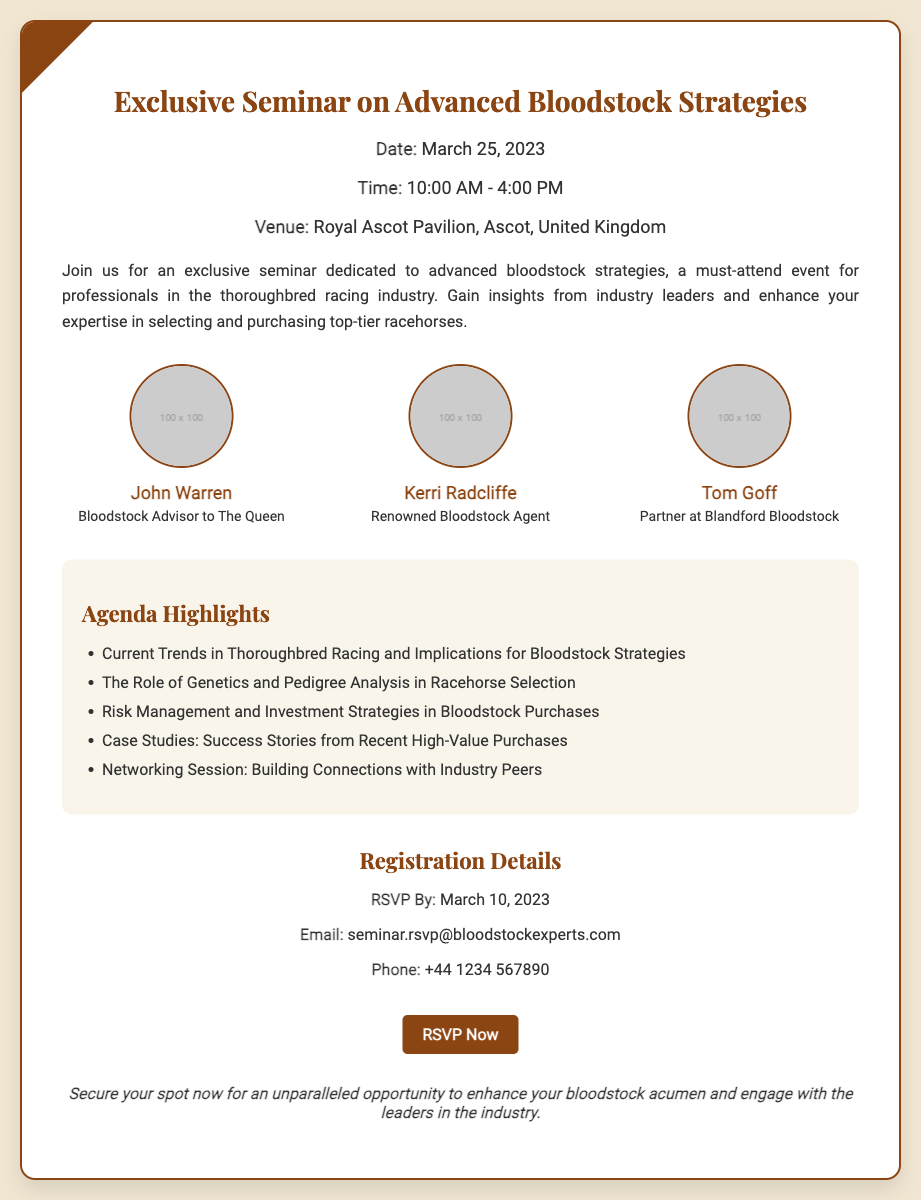what is the date of the seminar? The date of the seminar is stated clearly in the event details section of the document.
Answer: March 25, 2023 what is the venue for the seminar? The venue is specified in the event details section where the location is mentioned.
Answer: Royal Ascot Pavilion, Ascot, United Kingdom who is a speaker at the seminar? The document lists three speakers, each with their roles, under the speakers section.
Answer: John Warren what is the RSVP deadline? The RSVP deadline is provided in the registration details section of the document.
Answer: March 10, 2023 how long is the seminar scheduled to last? The time frame of the seminar is mentioned in the event details section, indicating the duration.
Answer: 6 hours what is one of the agenda highlights? The agenda highlights are listed, providing specific topics to be discussed during the seminar.
Answer: Current Trends in Thoroughbred Racing and Implications for Bloodstock Strategies what email should be used for the RSVP? The email for RSVP is given in the registration details section of the document.
Answer: seminar.rsvp@bloodstockexperts.com what type of event is this document for? The document outlines an event specifically designed for a professional audience within a defined sector.
Answer: Seminar 